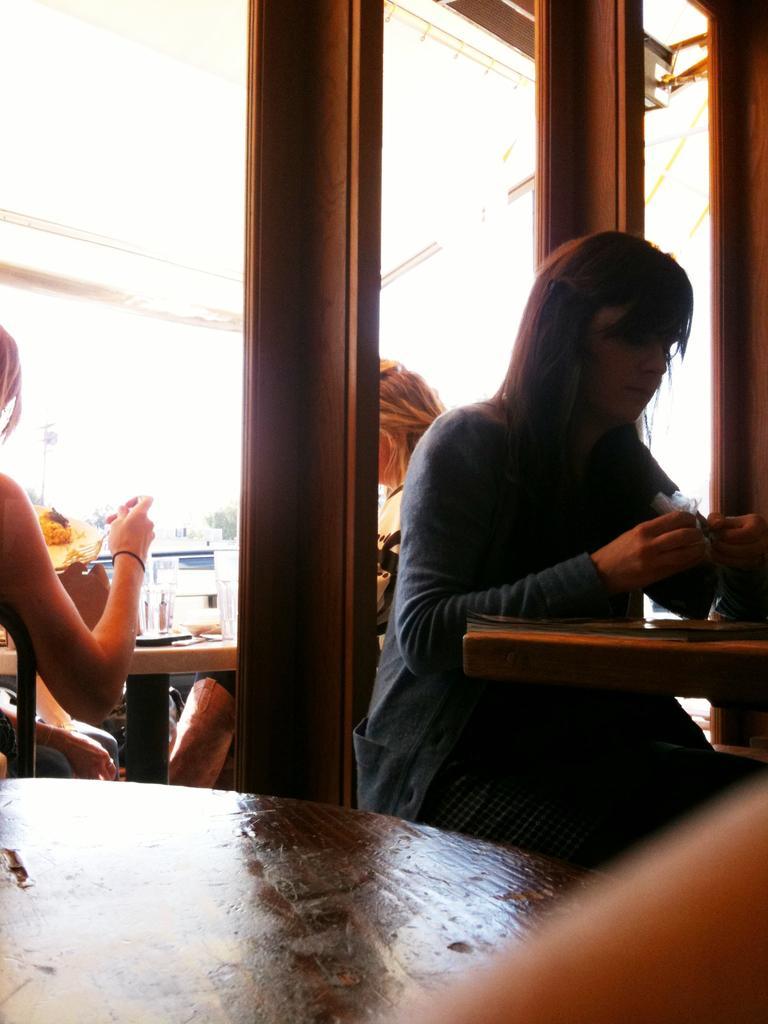Could you give a brief overview of what you see in this image? In this image on the right side there is one woman who is sitting. On the left side there are two persons who are sitting and there are some tables and three poles are there, on the top there is ceiling. 